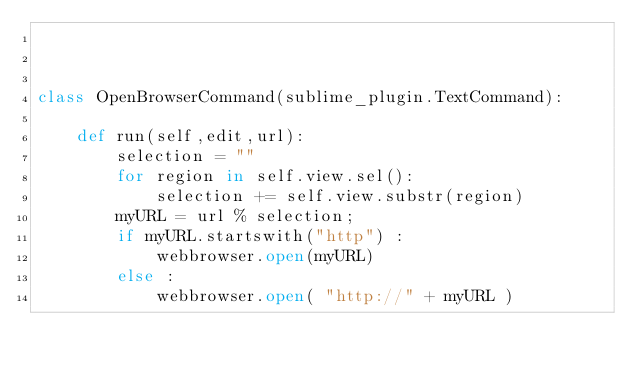Convert code to text. <code><loc_0><loc_0><loc_500><loc_500><_Python_>


class OpenBrowserCommand(sublime_plugin.TextCommand):

    def run(self,edit,url):
        selection = ""
        for region in self.view.sel():
            selection += self.view.substr(region)
        myURL = url % selection;
        if myURL.startswith("http") :
            webbrowser.open(myURL)
        else :
            webbrowser.open( "http://" + myURL )
</code> 